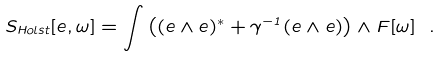Convert formula to latex. <formula><loc_0><loc_0><loc_500><loc_500>S _ { H o l s t } [ e , \omega ] = \int \left ( ( e \wedge e ) ^ { * } + \gamma ^ { - 1 } ( e \wedge e ) \right ) \wedge F [ \omega ] \ .</formula> 